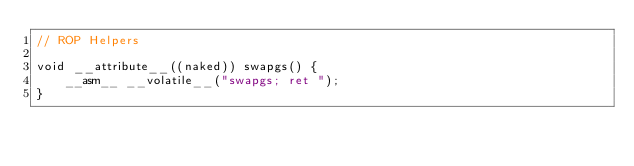<code> <loc_0><loc_0><loc_500><loc_500><_C_>// ROP Helpers

void __attribute__((naked)) swapgs() {
    __asm__ __volatile__("swapgs; ret ");
}</code> 